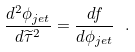Convert formula to latex. <formula><loc_0><loc_0><loc_500><loc_500>\frac { d ^ { 2 } \phi _ { j e t } } { d \widetilde { \tau } ^ { 2 } } = \frac { d f } { d \phi _ { j e t } } \ .</formula> 